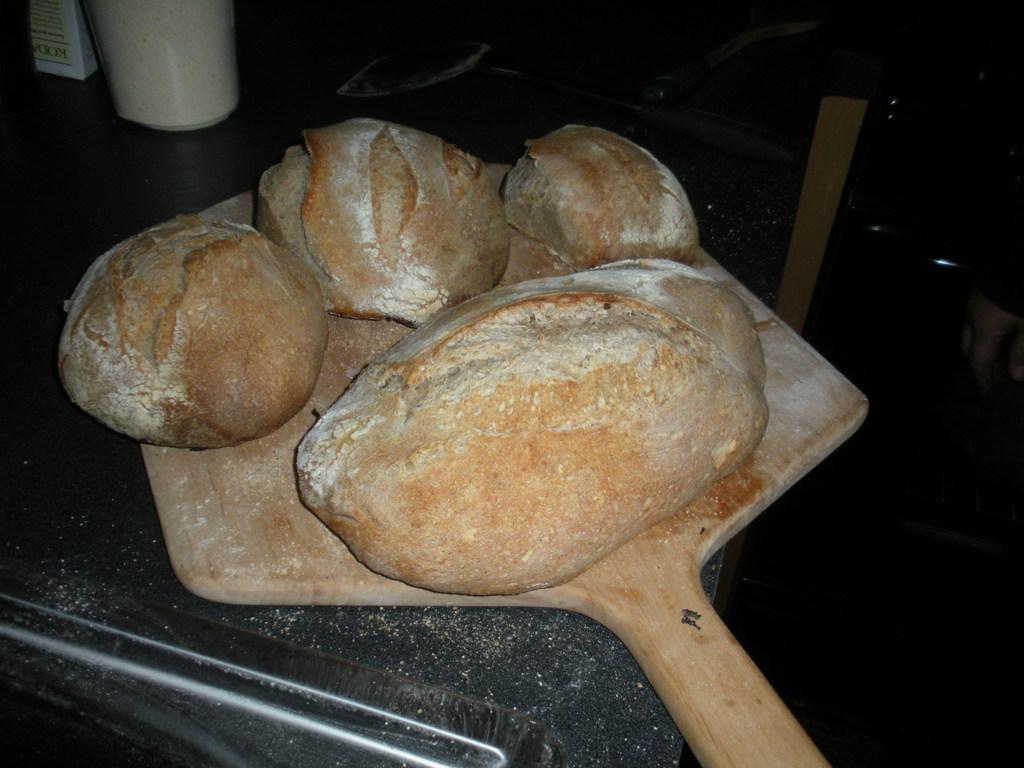Can you describe this image briefly? In this picture I can observe dough placed on the wooden plate. This wooden plate is placed on the black color table. The background is dark. 